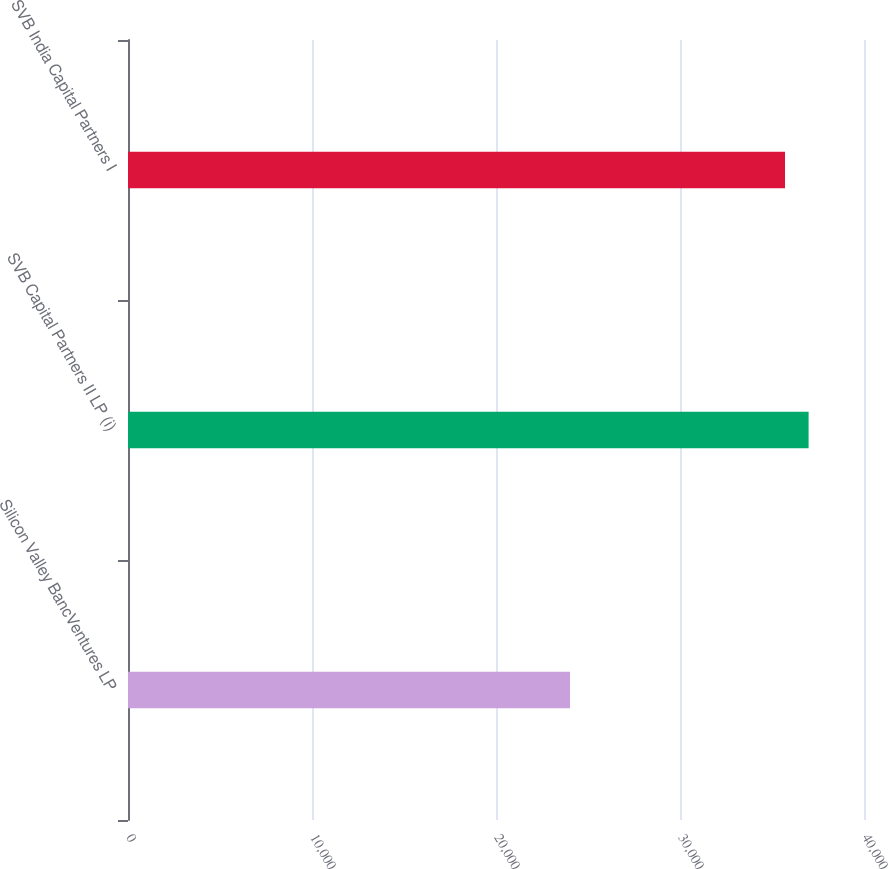Convert chart. <chart><loc_0><loc_0><loc_500><loc_500><bar_chart><fcel>Silicon Valley BancVentures LP<fcel>SVB Capital Partners II LP (i)<fcel>SVB India Capital Partners I<nl><fcel>24023<fcel>36989.4<fcel>35707<nl></chart> 